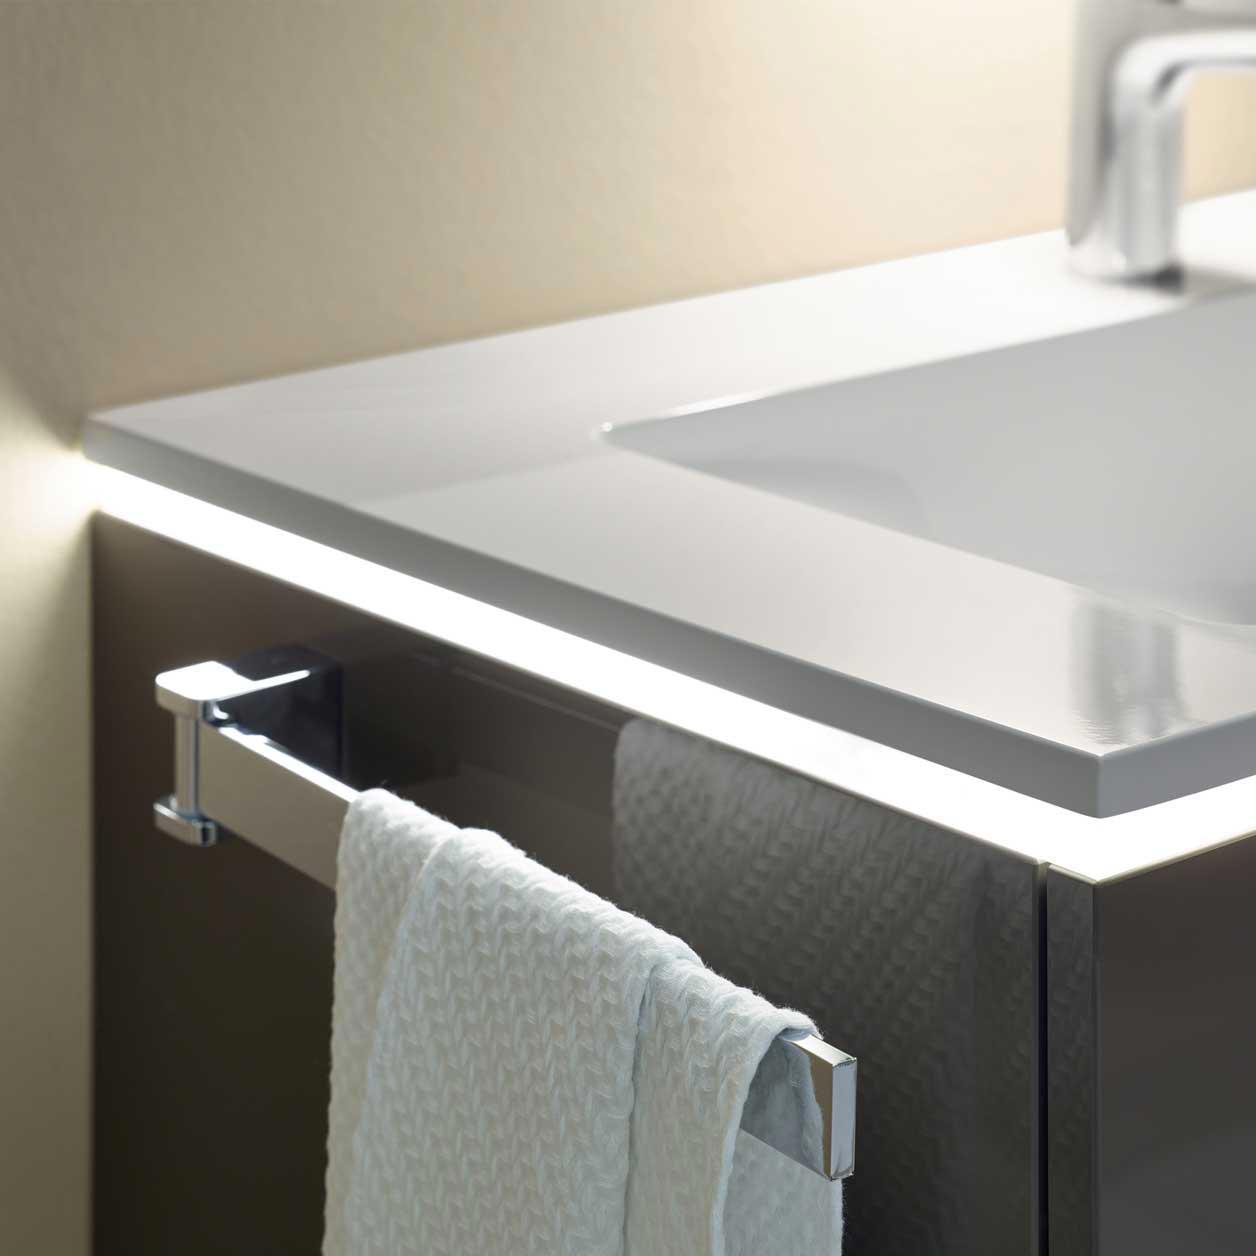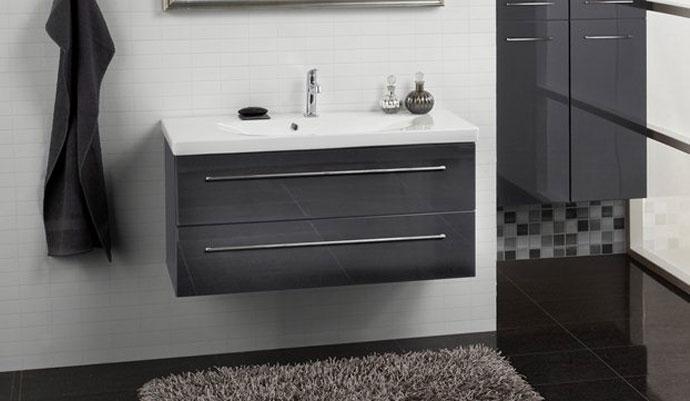The first image is the image on the left, the second image is the image on the right. For the images shown, is this caption "One of the sinks is inset in a rectangle above metal legs." true? Answer yes or no. No. 